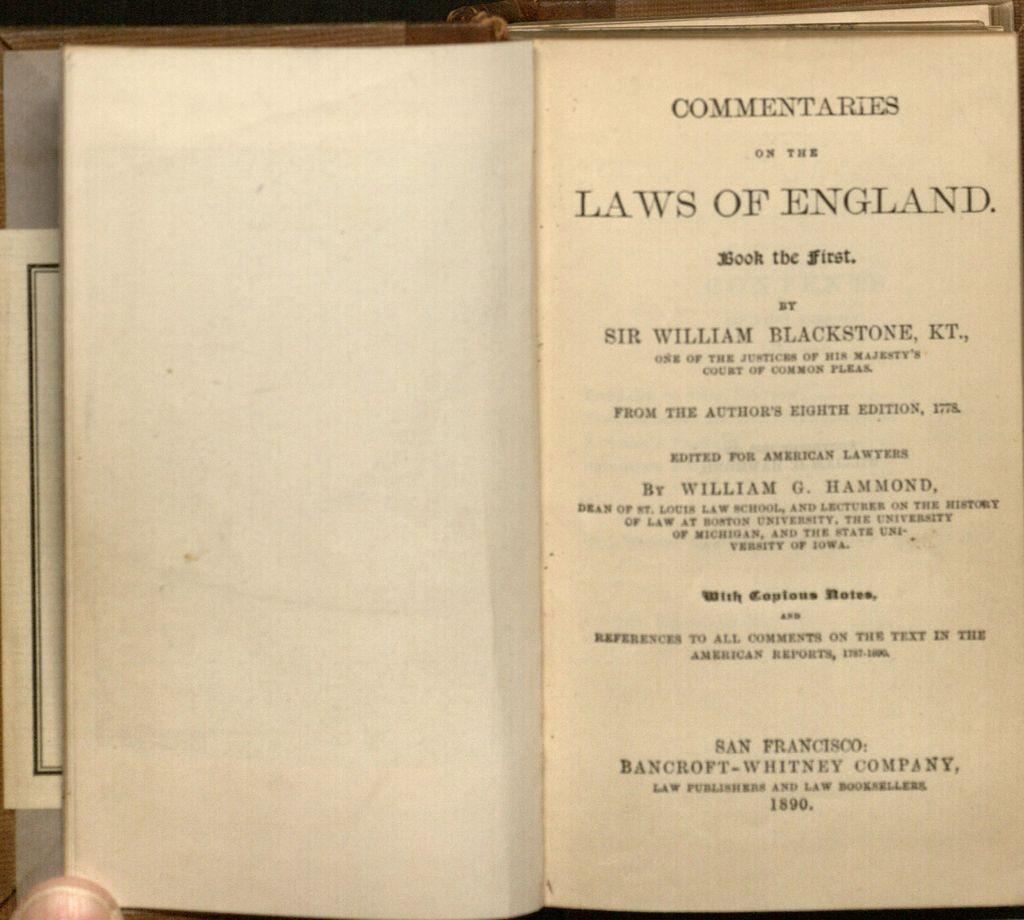Provide a one-sentence caption for the provided image. Laws of england commentaries chapter book by sir william blackstone. 